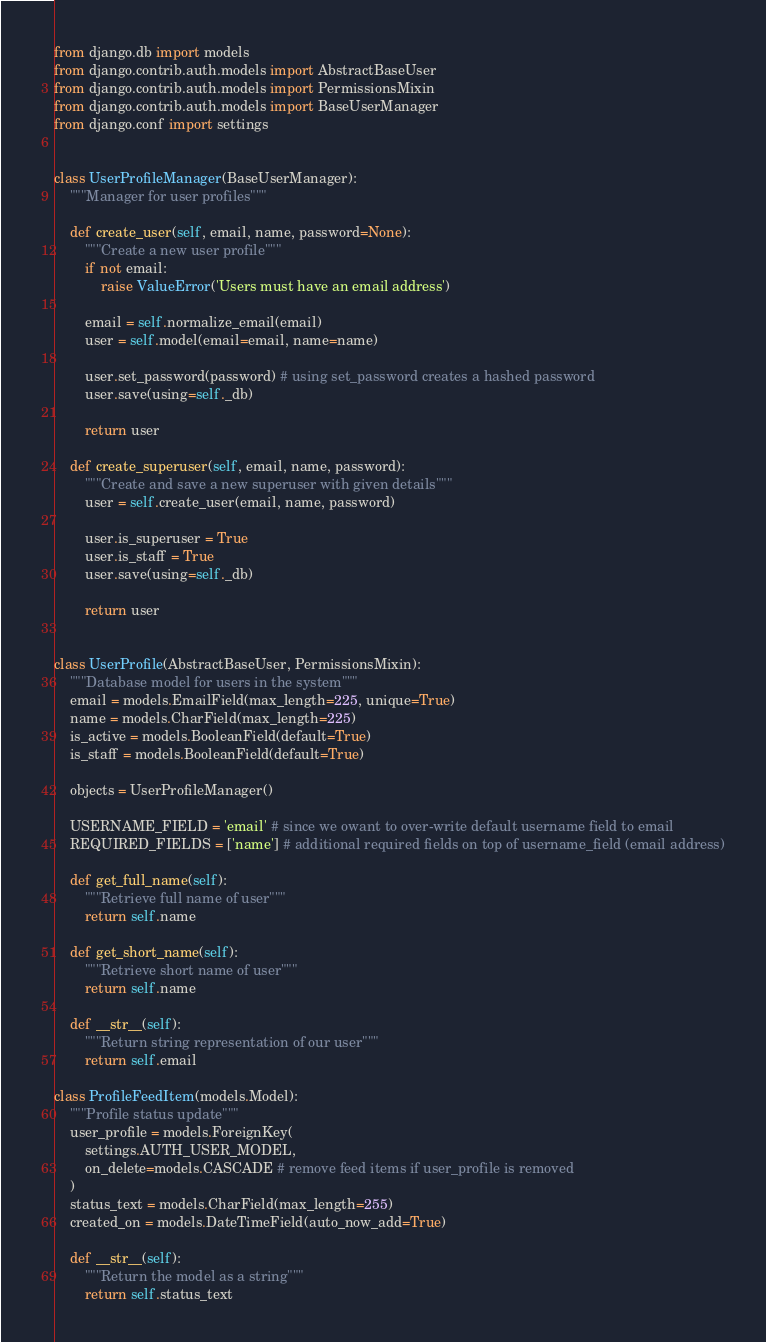<code> <loc_0><loc_0><loc_500><loc_500><_Python_>from django.db import models
from django.contrib.auth.models import AbstractBaseUser
from django.contrib.auth.models import PermissionsMixin
from django.contrib.auth.models import BaseUserManager
from django.conf import settings


class UserProfileManager(BaseUserManager):
    """Manager for user profiles"""

    def create_user(self, email, name, password=None):
        """Create a new user profile"""
        if not email:
            raise ValueError('Users must have an email address')

        email = self.normalize_email(email)
        user = self.model(email=email, name=name)

        user.set_password(password) # using set_password creates a hashed password
        user.save(using=self._db)

        return user

    def create_superuser(self, email, name, password):
        """Create and save a new superuser with given details"""
        user = self.create_user(email, name, password)

        user.is_superuser = True
        user.is_staff = True
        user.save(using=self._db)

        return user


class UserProfile(AbstractBaseUser, PermissionsMixin):
    """Database model for users in the system"""
    email = models.EmailField(max_length=225, unique=True)
    name = models.CharField(max_length=225)
    is_active = models.BooleanField(default=True)
    is_staff = models.BooleanField(default=True)

    objects = UserProfileManager()

    USERNAME_FIELD = 'email' # since we owant to over-write default username field to email
    REQUIRED_FIELDS = ['name'] # additional required fields on top of username_field (email address)

    def get_full_name(self):
        """Retrieve full name of user"""
        return self.name

    def get_short_name(self):
        """Retrieve short name of user"""
        return self.name

    def __str__(self):
        """Return string representation of our user"""
        return self.email

class ProfileFeedItem(models.Model):
    """Profile status update"""
    user_profile = models.ForeignKey(
        settings.AUTH_USER_MODEL,
        on_delete=models.CASCADE # remove feed items if user_profile is removed
    )
    status_text = models.CharField(max_length=255)
    created_on = models.DateTimeField(auto_now_add=True)

    def __str__(self):
        """Return the model as a string"""
        return self.status_text</code> 